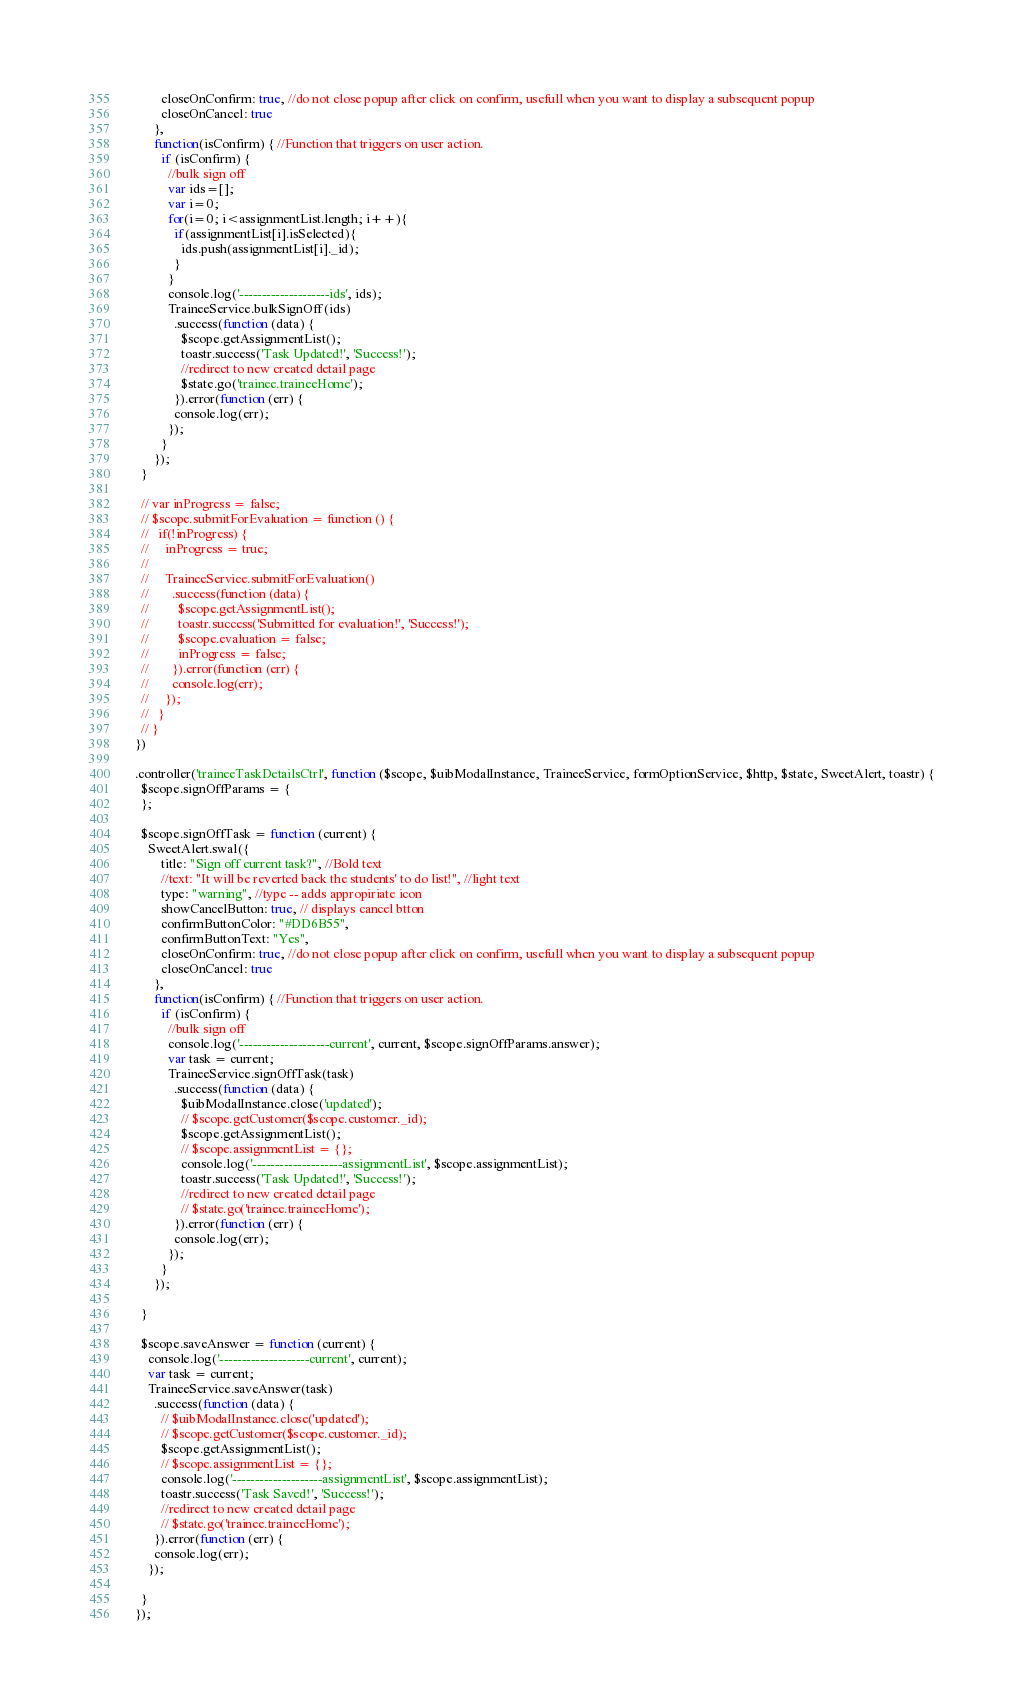Convert code to text. <code><loc_0><loc_0><loc_500><loc_500><_JavaScript_>          closeOnConfirm: true, //do not close popup after click on confirm, usefull when you want to display a subsequent popup
          closeOnCancel: true
        },
        function(isConfirm) { //Function that triggers on user action.
          if (isConfirm) {
            //bulk sign off
            var ids=[];
            var i=0;
            for(i=0; i<assignmentList.length; i++){
              if(assignmentList[i].isSelected){
                ids.push(assignmentList[i]._id);
              }
            }
            console.log('--------------------ids', ids);
            TraineeService.bulkSignOff(ids)
              .success(function (data) {
                $scope.getAssignmentList();
                toastr.success('Task Updated!', 'Success!');
                //redirect to new created detail page
                $state.go('trainee.traineeHome');
              }).error(function (err) {
              console.log(err);
            });
          }
        });
    }

    // var inProgress = false;
    // $scope.submitForEvaluation = function () {
    //   if(!inProgress) {
    //     inProgress = true;
    //
    //     TraineeService.submitForEvaluation()
    //       .success(function (data) {
    //         $scope.getAssignmentList();
    //         toastr.success('Submitted for evaluation!', 'Success!');
    //         $scope.evaluation = false;
    //         inProgress = false;
    //       }).error(function (err) {
    //       console.log(err);
    //     });
    //   }
    // }
  })

  .controller('traineeTaskDetailsCtrl', function ($scope, $uibModalInstance, TraineeService, formOptionService, $http, $state, SweetAlert, toastr) {
    $scope.signOffParams = {
    };

    $scope.signOffTask = function (current) {
      SweetAlert.swal({
          title: "Sign off current task?", //Bold text
          //text: "It will be reverted back the students' to do list!", //light text
          type: "warning", //type -- adds appropiriate icon
          showCancelButton: true, // displays cancel btton
          confirmButtonColor: "#DD6B55",
          confirmButtonText: "Yes",
          closeOnConfirm: true, //do not close popup after click on confirm, usefull when you want to display a subsequent popup
          closeOnCancel: true
        },
        function(isConfirm) { //Function that triggers on user action.
          if (isConfirm) {
            //bulk sign off
            console.log('--------------------current', current, $scope.signOffParams.answer);
            var task = current;
            TraineeService.signOffTask(task)
              .success(function (data) {
                $uibModalInstance.close('updated');
                // $scope.getCustomer($scope.customer._id);
                $scope.getAssignmentList();
                // $scope.assignmentList = {};
                console.log('--------------------assignmentList', $scope.assignmentList);
                toastr.success('Task Updated!', 'Success!');
                //redirect to new created detail page
                // $state.go('trainee.traineeHome');
              }).error(function (err) {
              console.log(err);
            });
          }
        });

    }

    $scope.saveAnswer = function (current) {
      console.log('--------------------current', current);
      var task = current;
      TraineeService.saveAnswer(task)
        .success(function (data) {
          // $uibModalInstance.close('updated');
          // $scope.getCustomer($scope.customer._id);
          $scope.getAssignmentList();
          // $scope.assignmentList = {};
          console.log('--------------------assignmentList', $scope.assignmentList);
          toastr.success('Task Saved!', 'Success!');
          //redirect to new created detail page
          // $state.go('trainee.traineeHome');
        }).error(function (err) {
        console.log(err);
      });

    }
  });
</code> 